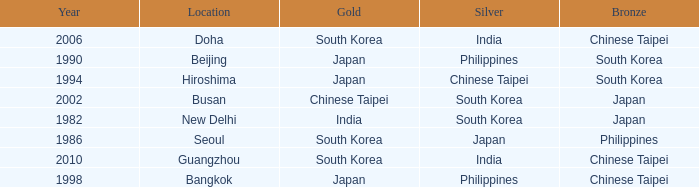Which Bronze has a Year smaller than 1994, and a Silver of south korea? Japan. 